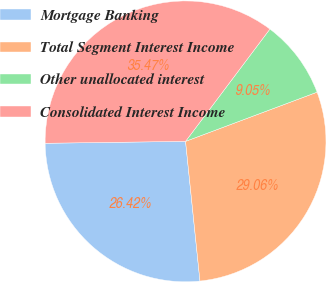Convert chart to OTSL. <chart><loc_0><loc_0><loc_500><loc_500><pie_chart><fcel>Mortgage Banking<fcel>Total Segment Interest Income<fcel>Other unallocated interest<fcel>Consolidated Interest Income<nl><fcel>26.42%<fcel>29.06%<fcel>9.05%<fcel>35.47%<nl></chart> 